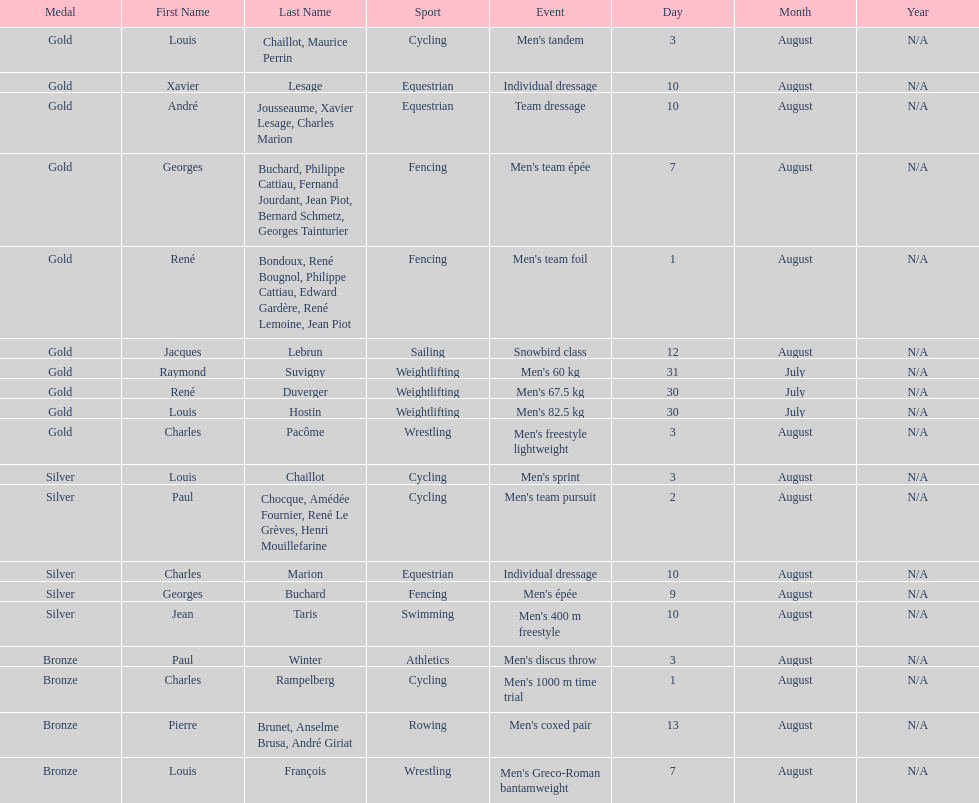How many medals were won after august 3? 9. Write the full table. {'header': ['Medal', 'First Name', 'Last Name', 'Sport', 'Event', 'Day', 'Month', 'Year'], 'rows': [['Gold', 'Louis', 'Chaillot, Maurice Perrin', 'Cycling', "Men's tandem", '3', 'August', 'N/A'], ['Gold', 'Xavier', 'Lesage', 'Equestrian', 'Individual dressage', '10', 'August', 'N/A'], ['Gold', 'André', 'Jousseaume, Xavier Lesage, Charles Marion', 'Equestrian', 'Team dressage', '10', 'August', 'N/A'], ['Gold', 'Georges', 'Buchard, Philippe Cattiau, Fernand Jourdant, Jean Piot, Bernard Schmetz, Georges Tainturier', 'Fencing', "Men's team épée", '7', 'August', 'N/A'], ['Gold', 'René', 'Bondoux, René Bougnol, Philippe Cattiau, Edward Gardère, René Lemoine, Jean Piot', 'Fencing', "Men's team foil", '1', 'August', 'N/A'], ['Gold', 'Jacques', 'Lebrun', 'Sailing', 'Snowbird class', '12', 'August', 'N/A'], ['Gold', 'Raymond', 'Suvigny', 'Weightlifting', "Men's 60 kg", '31', 'July', 'N/A'], ['Gold', 'René', 'Duverger', 'Weightlifting', "Men's 67.5 kg", '30', 'July', 'N/A'], ['Gold', 'Louis', 'Hostin', 'Weightlifting', "Men's 82.5 kg", '30', 'July', 'N/A'], ['Gold', 'Charles', 'Pacôme', 'Wrestling', "Men's freestyle lightweight", '3', 'August', 'N/A'], ['Silver', 'Louis', 'Chaillot', 'Cycling', "Men's sprint", '3', 'August', 'N/A'], ['Silver', 'Paul', 'Chocque, Amédée Fournier, René Le Grèves, Henri Mouillefarine', 'Cycling', "Men's team pursuit", '2', 'August', 'N/A'], ['Silver', 'Charles', 'Marion', 'Equestrian', 'Individual dressage', '10', 'August', 'N/A'], ['Silver', 'Georges', 'Buchard', 'Fencing', "Men's épée", '9', 'August', 'N/A'], ['Silver', 'Jean', 'Taris', 'Swimming', "Men's 400 m freestyle", '10', 'August', 'N/A'], ['Bronze', 'Paul', 'Winter', 'Athletics', "Men's discus throw", '3', 'August', 'N/A'], ['Bronze', 'Charles', 'Rampelberg', 'Cycling', "Men's 1000 m time trial", '1', 'August', 'N/A'], ['Bronze', 'Pierre', 'Brunet, Anselme Brusa, André Giriat', 'Rowing', "Men's coxed pair", '13', 'August', 'N/A'], ['Bronze', 'Louis', 'François', 'Wrestling', "Men's Greco-Roman bantamweight", '7', 'August', 'N/A']]} 